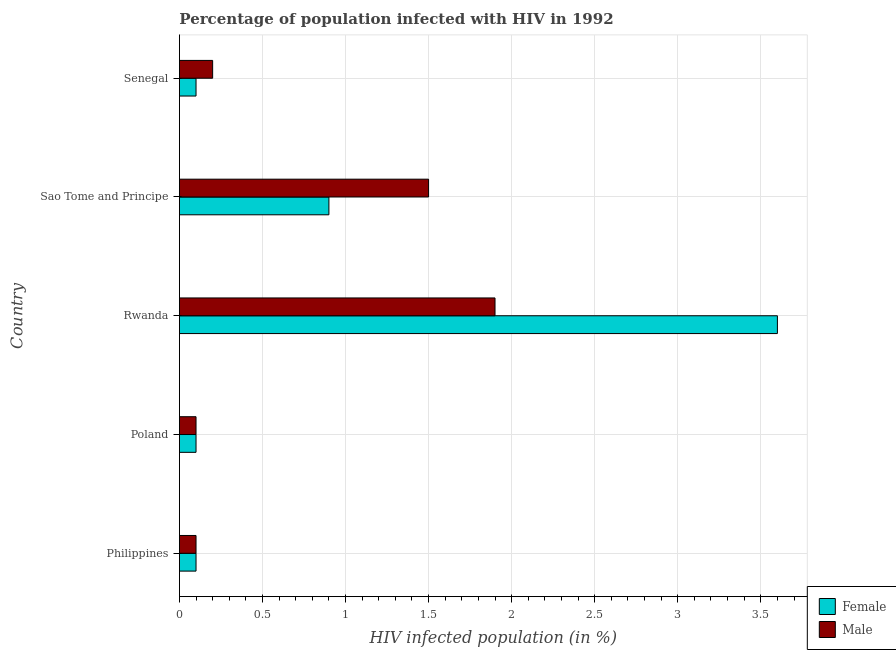How many groups of bars are there?
Your response must be concise. 5. How many bars are there on the 4th tick from the bottom?
Keep it short and to the point. 2. What is the label of the 1st group of bars from the top?
Give a very brief answer. Senegal. In which country was the percentage of females who are infected with hiv maximum?
Your response must be concise. Rwanda. What is the total percentage of females who are infected with hiv in the graph?
Offer a very short reply. 4.8. What is the difference between the percentage of females who are infected with hiv in Sao Tome and Principe and the percentage of males who are infected with hiv in Rwanda?
Ensure brevity in your answer.  -1. What is the average percentage of females who are infected with hiv per country?
Ensure brevity in your answer.  0.96. What is the difference between the percentage of males who are infected with hiv and percentage of females who are infected with hiv in Philippines?
Keep it short and to the point. 0. In how many countries, is the percentage of males who are infected with hiv greater than 1.1 %?
Offer a very short reply. 2. What is the ratio of the percentage of females who are infected with hiv in Poland to that in Sao Tome and Principe?
Offer a very short reply. 0.11. Is the difference between the percentage of males who are infected with hiv in Philippines and Sao Tome and Principe greater than the difference between the percentage of females who are infected with hiv in Philippines and Sao Tome and Principe?
Your response must be concise. No. What is the difference between the highest and the second highest percentage of males who are infected with hiv?
Provide a short and direct response. 0.4. What is the difference between the highest and the lowest percentage of males who are infected with hiv?
Your answer should be very brief. 1.8. What does the 2nd bar from the top in Senegal represents?
Your answer should be very brief. Female. How many bars are there?
Your answer should be very brief. 10. How many countries are there in the graph?
Your answer should be very brief. 5. Does the graph contain any zero values?
Your response must be concise. No. How are the legend labels stacked?
Ensure brevity in your answer.  Vertical. What is the title of the graph?
Offer a very short reply. Percentage of population infected with HIV in 1992. What is the label or title of the X-axis?
Provide a short and direct response. HIV infected population (in %). What is the label or title of the Y-axis?
Provide a short and direct response. Country. What is the HIV infected population (in %) in Female in Philippines?
Your answer should be compact. 0.1. What is the HIV infected population (in %) of Male in Philippines?
Ensure brevity in your answer.  0.1. What is the HIV infected population (in %) of Female in Poland?
Make the answer very short. 0.1. What is the HIV infected population (in %) of Male in Poland?
Your response must be concise. 0.1. What is the HIV infected population (in %) in Male in Rwanda?
Your response must be concise. 1.9. What is the HIV infected population (in %) of Female in Sao Tome and Principe?
Offer a terse response. 0.9. What is the HIV infected population (in %) in Male in Sao Tome and Principe?
Keep it short and to the point. 1.5. What is the HIV infected population (in %) of Male in Senegal?
Offer a terse response. 0.2. Across all countries, what is the maximum HIV infected population (in %) in Female?
Provide a succinct answer. 3.6. Across all countries, what is the minimum HIV infected population (in %) in Male?
Give a very brief answer. 0.1. What is the total HIV infected population (in %) of Male in the graph?
Provide a short and direct response. 3.8. What is the difference between the HIV infected population (in %) of Male in Philippines and that in Poland?
Your answer should be very brief. 0. What is the difference between the HIV infected population (in %) in Male in Philippines and that in Rwanda?
Offer a terse response. -1.8. What is the difference between the HIV infected population (in %) of Female in Philippines and that in Sao Tome and Principe?
Offer a very short reply. -0.8. What is the difference between the HIV infected population (in %) of Male in Philippines and that in Sao Tome and Principe?
Offer a very short reply. -1.4. What is the difference between the HIV infected population (in %) of Female in Poland and that in Rwanda?
Your answer should be very brief. -3.5. What is the difference between the HIV infected population (in %) of Male in Poland and that in Senegal?
Keep it short and to the point. -0.1. What is the difference between the HIV infected population (in %) of Female in Rwanda and that in Sao Tome and Principe?
Your response must be concise. 2.7. What is the difference between the HIV infected population (in %) of Male in Rwanda and that in Sao Tome and Principe?
Offer a terse response. 0.4. What is the difference between the HIV infected population (in %) of Female in Rwanda and that in Senegal?
Your response must be concise. 3.5. What is the difference between the HIV infected population (in %) in Male in Rwanda and that in Senegal?
Provide a succinct answer. 1.7. What is the difference between the HIV infected population (in %) of Female in Philippines and the HIV infected population (in %) of Male in Sao Tome and Principe?
Offer a very short reply. -1.4. What is the difference between the HIV infected population (in %) in Female in Philippines and the HIV infected population (in %) in Male in Senegal?
Your response must be concise. -0.1. What is the difference between the HIV infected population (in %) in Female in Poland and the HIV infected population (in %) in Male in Rwanda?
Provide a short and direct response. -1.8. What is the difference between the HIV infected population (in %) in Female in Poland and the HIV infected population (in %) in Male in Sao Tome and Principe?
Ensure brevity in your answer.  -1.4. What is the difference between the HIV infected population (in %) in Female in Rwanda and the HIV infected population (in %) in Male in Sao Tome and Principe?
Your response must be concise. 2.1. What is the average HIV infected population (in %) in Male per country?
Provide a short and direct response. 0.76. What is the difference between the HIV infected population (in %) in Female and HIV infected population (in %) in Male in Philippines?
Give a very brief answer. 0. What is the difference between the HIV infected population (in %) of Female and HIV infected population (in %) of Male in Rwanda?
Your answer should be very brief. 1.7. What is the difference between the HIV infected population (in %) in Female and HIV infected population (in %) in Male in Senegal?
Provide a succinct answer. -0.1. What is the ratio of the HIV infected population (in %) of Female in Philippines to that in Poland?
Keep it short and to the point. 1. What is the ratio of the HIV infected population (in %) in Female in Philippines to that in Rwanda?
Provide a short and direct response. 0.03. What is the ratio of the HIV infected population (in %) of Male in Philippines to that in Rwanda?
Your response must be concise. 0.05. What is the ratio of the HIV infected population (in %) in Female in Philippines to that in Sao Tome and Principe?
Provide a succinct answer. 0.11. What is the ratio of the HIV infected population (in %) of Male in Philippines to that in Sao Tome and Principe?
Give a very brief answer. 0.07. What is the ratio of the HIV infected population (in %) in Female in Poland to that in Rwanda?
Your answer should be compact. 0.03. What is the ratio of the HIV infected population (in %) in Male in Poland to that in Rwanda?
Provide a short and direct response. 0.05. What is the ratio of the HIV infected population (in %) in Female in Poland to that in Sao Tome and Principe?
Offer a very short reply. 0.11. What is the ratio of the HIV infected population (in %) of Male in Poland to that in Sao Tome and Principe?
Make the answer very short. 0.07. What is the ratio of the HIV infected population (in %) in Female in Poland to that in Senegal?
Offer a very short reply. 1. What is the ratio of the HIV infected population (in %) in Male in Rwanda to that in Sao Tome and Principe?
Offer a very short reply. 1.27. What is the ratio of the HIV infected population (in %) of Female in Rwanda to that in Senegal?
Offer a very short reply. 36. What is the difference between the highest and the second highest HIV infected population (in %) in Female?
Your answer should be very brief. 2.7. What is the difference between the highest and the second highest HIV infected population (in %) of Male?
Your answer should be compact. 0.4. 